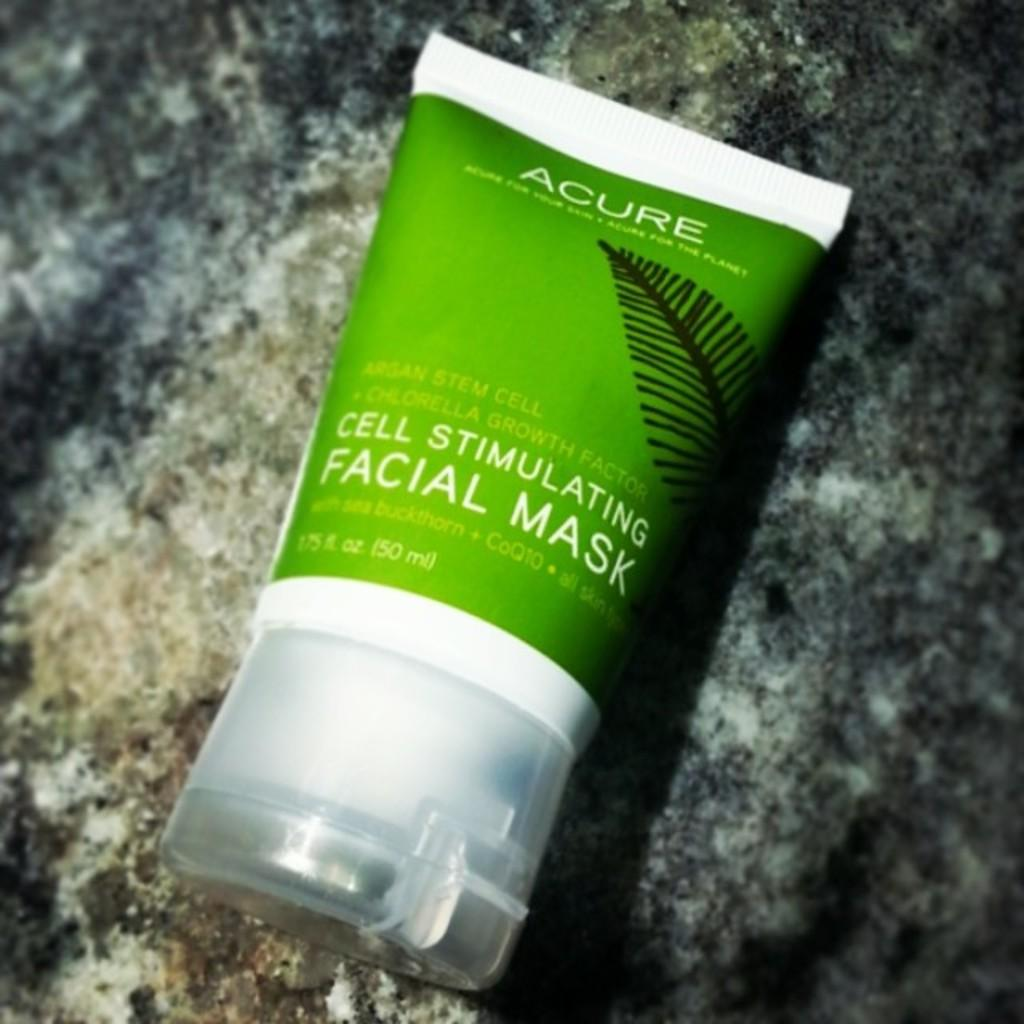<image>
Summarize the visual content of the image. A bottle of Acure facial mask is cell stimulating. 